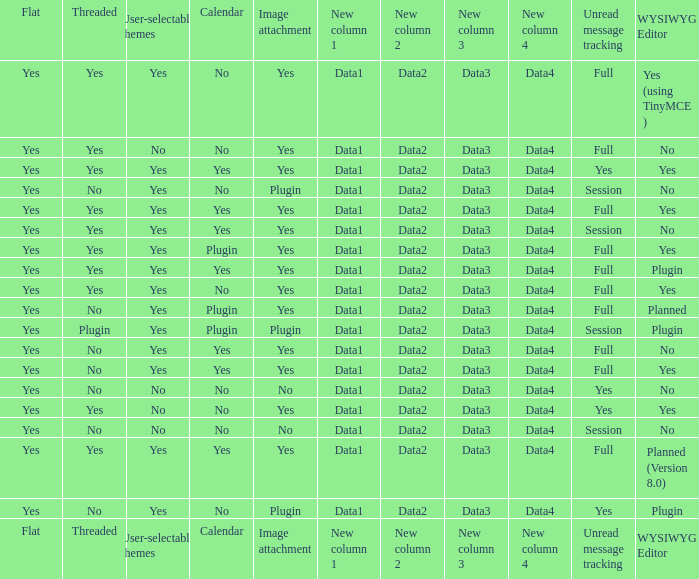Which WYSIWYG Editor has a User-selectable themes of yes, and an Unread message tracking of session, and an Image attachment of plugin? No, Plugin. 